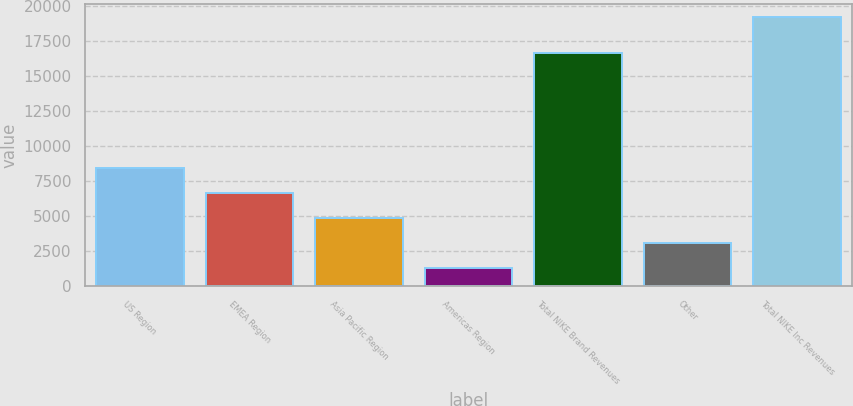Convert chart. <chart><loc_0><loc_0><loc_500><loc_500><bar_chart><fcel>US Region<fcel>EMEA Region<fcel>Asia Pacific Region<fcel>Americas Region<fcel>Total NIKE Brand Revenues<fcel>Other<fcel>Total NIKE Inc Revenues<nl><fcel>8441.26<fcel>6652.12<fcel>4862.98<fcel>1284.7<fcel>16661.8<fcel>3073.84<fcel>19176.1<nl></chart> 